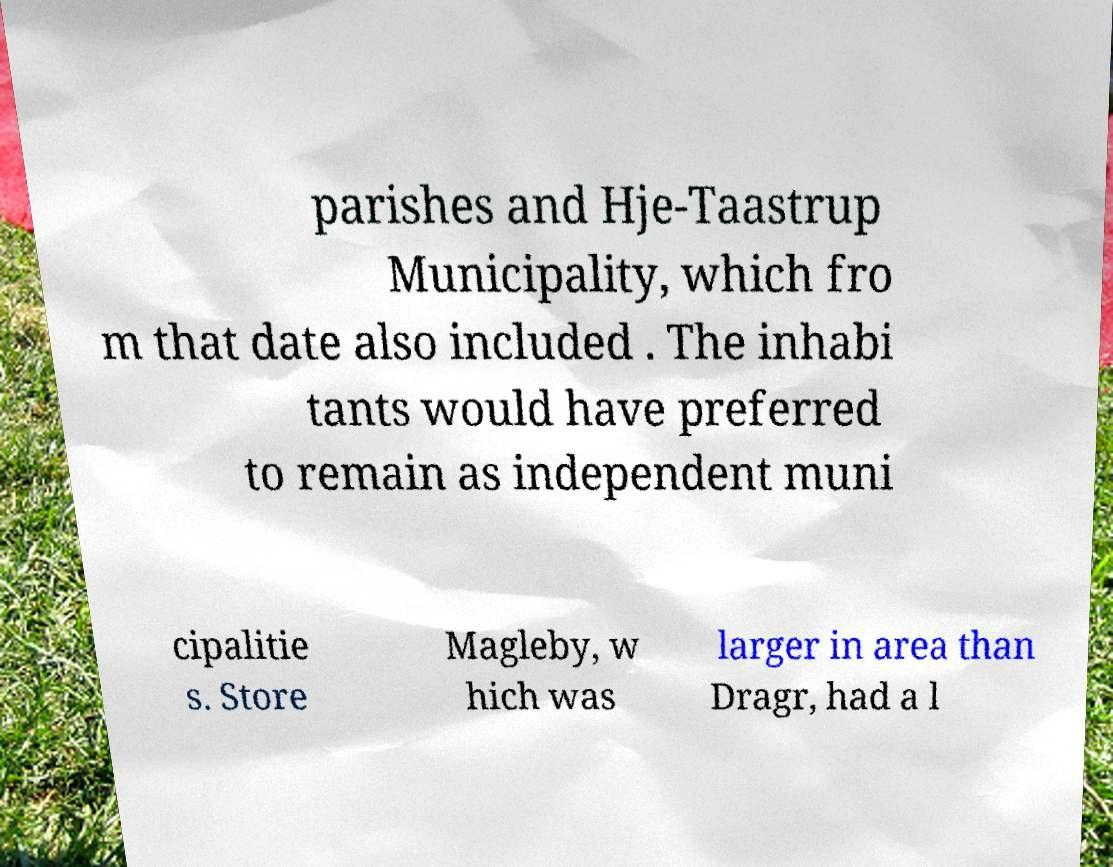Please read and relay the text visible in this image. What does it say? parishes and Hje-Taastrup Municipality, which fro m that date also included . The inhabi tants would have preferred to remain as independent muni cipalitie s. Store Magleby, w hich was larger in area than Dragr, had a l 